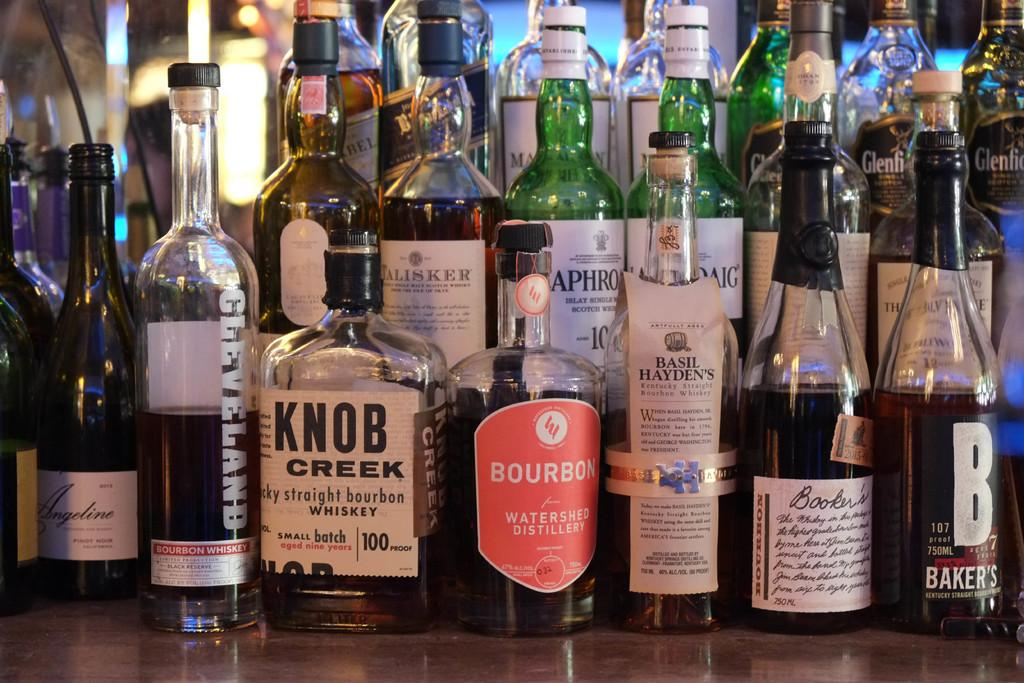<image>
Create a compact narrative representing the image presented. Various bottles of bourbon whisky lined up on a wooden counter. 